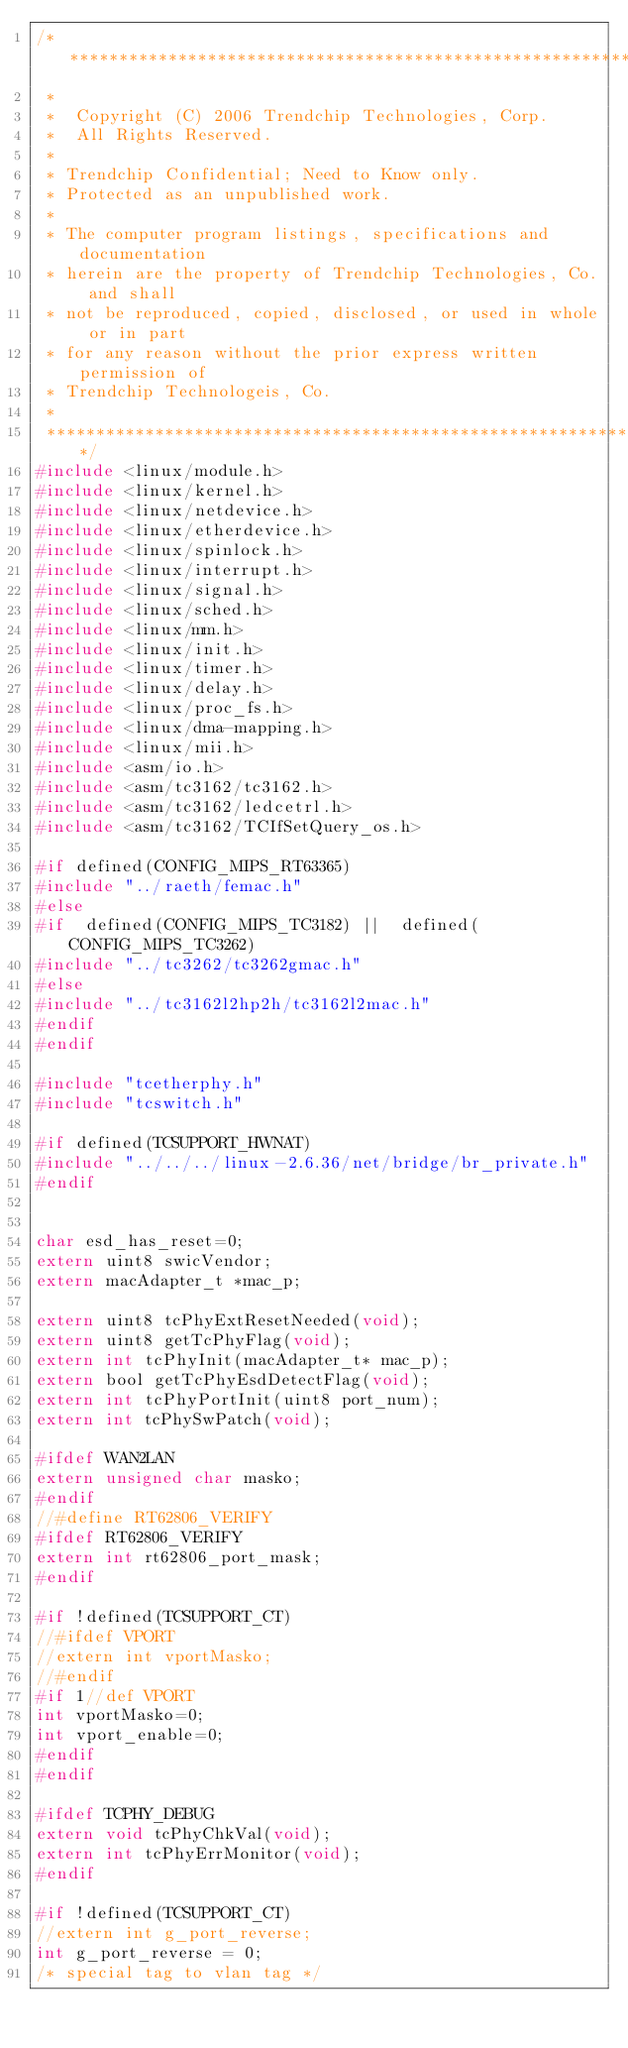<code> <loc_0><loc_0><loc_500><loc_500><_C_>/************************************************************************
 *
 *	Copyright (C) 2006 Trendchip Technologies, Corp.
 *	All Rights Reserved.
 *
 * Trendchip Confidential; Need to Know only.
 * Protected as an unpublished work.
 *
 * The computer program listings, specifications and documentation
 * herein are the property of Trendchip Technologies, Co. and shall
 * not be reproduced, copied, disclosed, or used in whole or in part
 * for any reason without the prior express written permission of
 * Trendchip Technologeis, Co.
 *
 *************************************************************************/
#include <linux/module.h>
#include <linux/kernel.h>
#include <linux/netdevice.h>
#include <linux/etherdevice.h>
#include <linux/spinlock.h>
#include <linux/interrupt.h>
#include <linux/signal.h>
#include <linux/sched.h>
#include <linux/mm.h>
#include <linux/init.h>
#include <linux/timer.h>
#include <linux/delay.h>
#include <linux/proc_fs.h>
#include <linux/dma-mapping.h>
#include <linux/mii.h>
#include <asm/io.h>
#include <asm/tc3162/tc3162.h>
#include <asm/tc3162/ledcetrl.h>
#include <asm/tc3162/TCIfSetQuery_os.h>

#if defined(CONFIG_MIPS_RT63365)
#include "../raeth/femac.h"
#else
#if  defined(CONFIG_MIPS_TC3182) ||  defined(CONFIG_MIPS_TC3262)
#include "../tc3262/tc3262gmac.h"
#else
#include "../tc3162l2hp2h/tc3162l2mac.h"
#endif
#endif

#include "tcetherphy.h"
#include "tcswitch.h"

#if defined(TCSUPPORT_HWNAT)
#include "../../../linux-2.6.36/net/bridge/br_private.h"
#endif


char esd_has_reset=0;
extern uint8 swicVendor;
extern macAdapter_t *mac_p;

extern uint8 tcPhyExtResetNeeded(void);
extern uint8 getTcPhyFlag(void);
extern int tcPhyInit(macAdapter_t* mac_p);
extern bool getTcPhyEsdDetectFlag(void);
extern int tcPhyPortInit(uint8 port_num);
extern int tcPhySwPatch(void);

#ifdef WAN2LAN
extern unsigned char masko;
#endif
//#define RT62806_VERIFY
#ifdef RT62806_VERIFY
extern int rt62806_port_mask;
#endif

#if !defined(TCSUPPORT_CT)
//#ifdef VPORT
//extern int vportMasko;
//#endif
#if 1//def VPORT
int vportMasko=0;
int vport_enable=0;
#endif
#endif

#ifdef TCPHY_DEBUG
extern void tcPhyChkVal(void);
extern int tcPhyErrMonitor(void);
#endif

#if !defined(TCSUPPORT_CT) 
//extern int g_port_reverse;
int g_port_reverse = 0;
/* special tag to vlan tag */</code> 